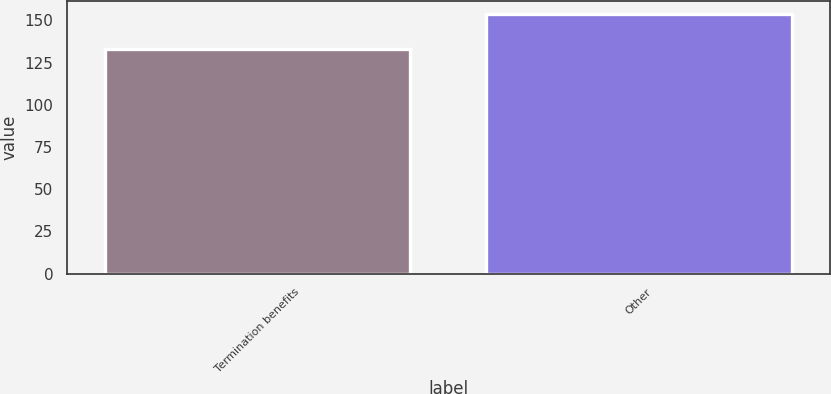Convert chart to OTSL. <chart><loc_0><loc_0><loc_500><loc_500><bar_chart><fcel>Termination benefits<fcel>Other<nl><fcel>133<fcel>154<nl></chart> 